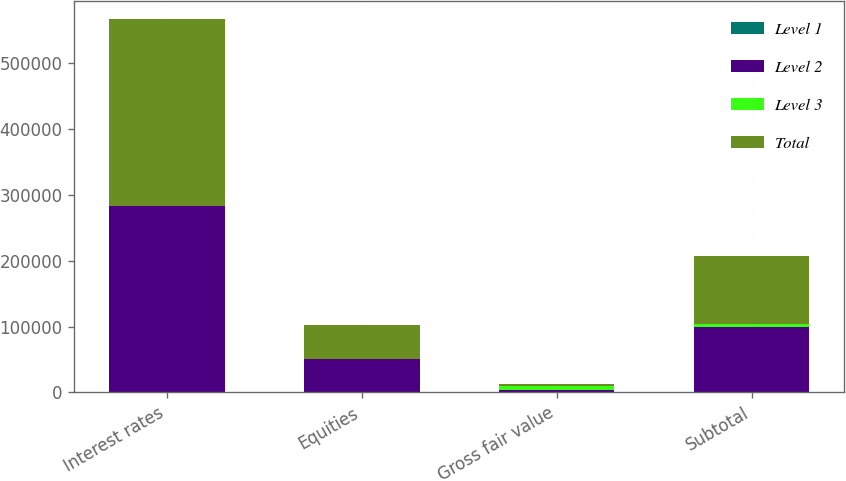<chart> <loc_0><loc_0><loc_500><loc_500><stacked_bar_chart><ecel><fcel>Interest rates<fcel>Equities<fcel>Gross fair value<fcel>Subtotal<nl><fcel>Level 1<fcel>18<fcel>8<fcel>26<fcel>26<nl><fcel>Level 2<fcel>282933<fcel>50870<fcel>4327.5<fcel>99875<nl><fcel>Level 3<fcel>311<fcel>409<fcel>4853<fcel>3802<nl><fcel>Total<fcel>283262<fcel>51287<fcel>4327.5<fcel>103703<nl></chart> 